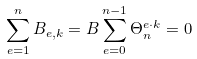<formula> <loc_0><loc_0><loc_500><loc_500>\sum _ { e = 1 } ^ { n } B _ { e , k } = B \sum _ { e = 0 } ^ { n - 1 } \Theta _ { n } ^ { e \cdot k } = 0</formula> 